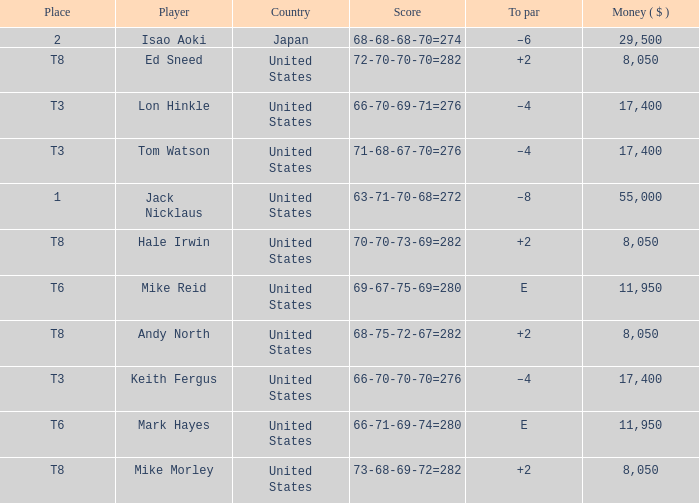What to par is located in the united states and has the player by the name of hale irwin? 2.0. 